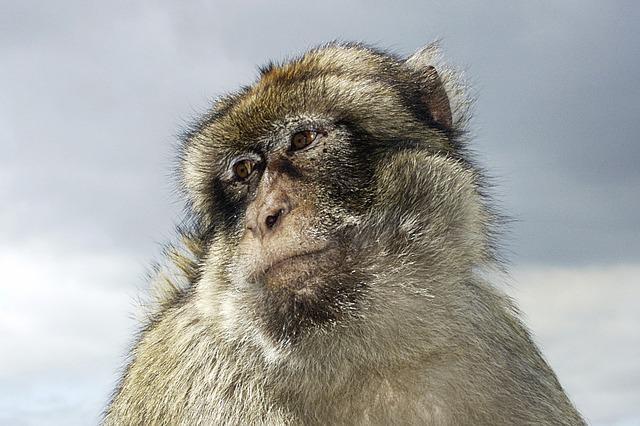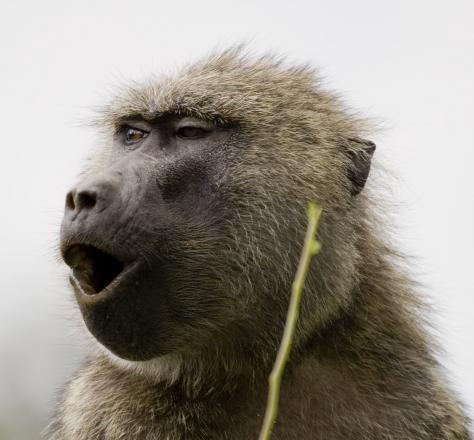The first image is the image on the left, the second image is the image on the right. For the images shown, is this caption "One monkey is showing its teeth" true? Answer yes or no. No. 